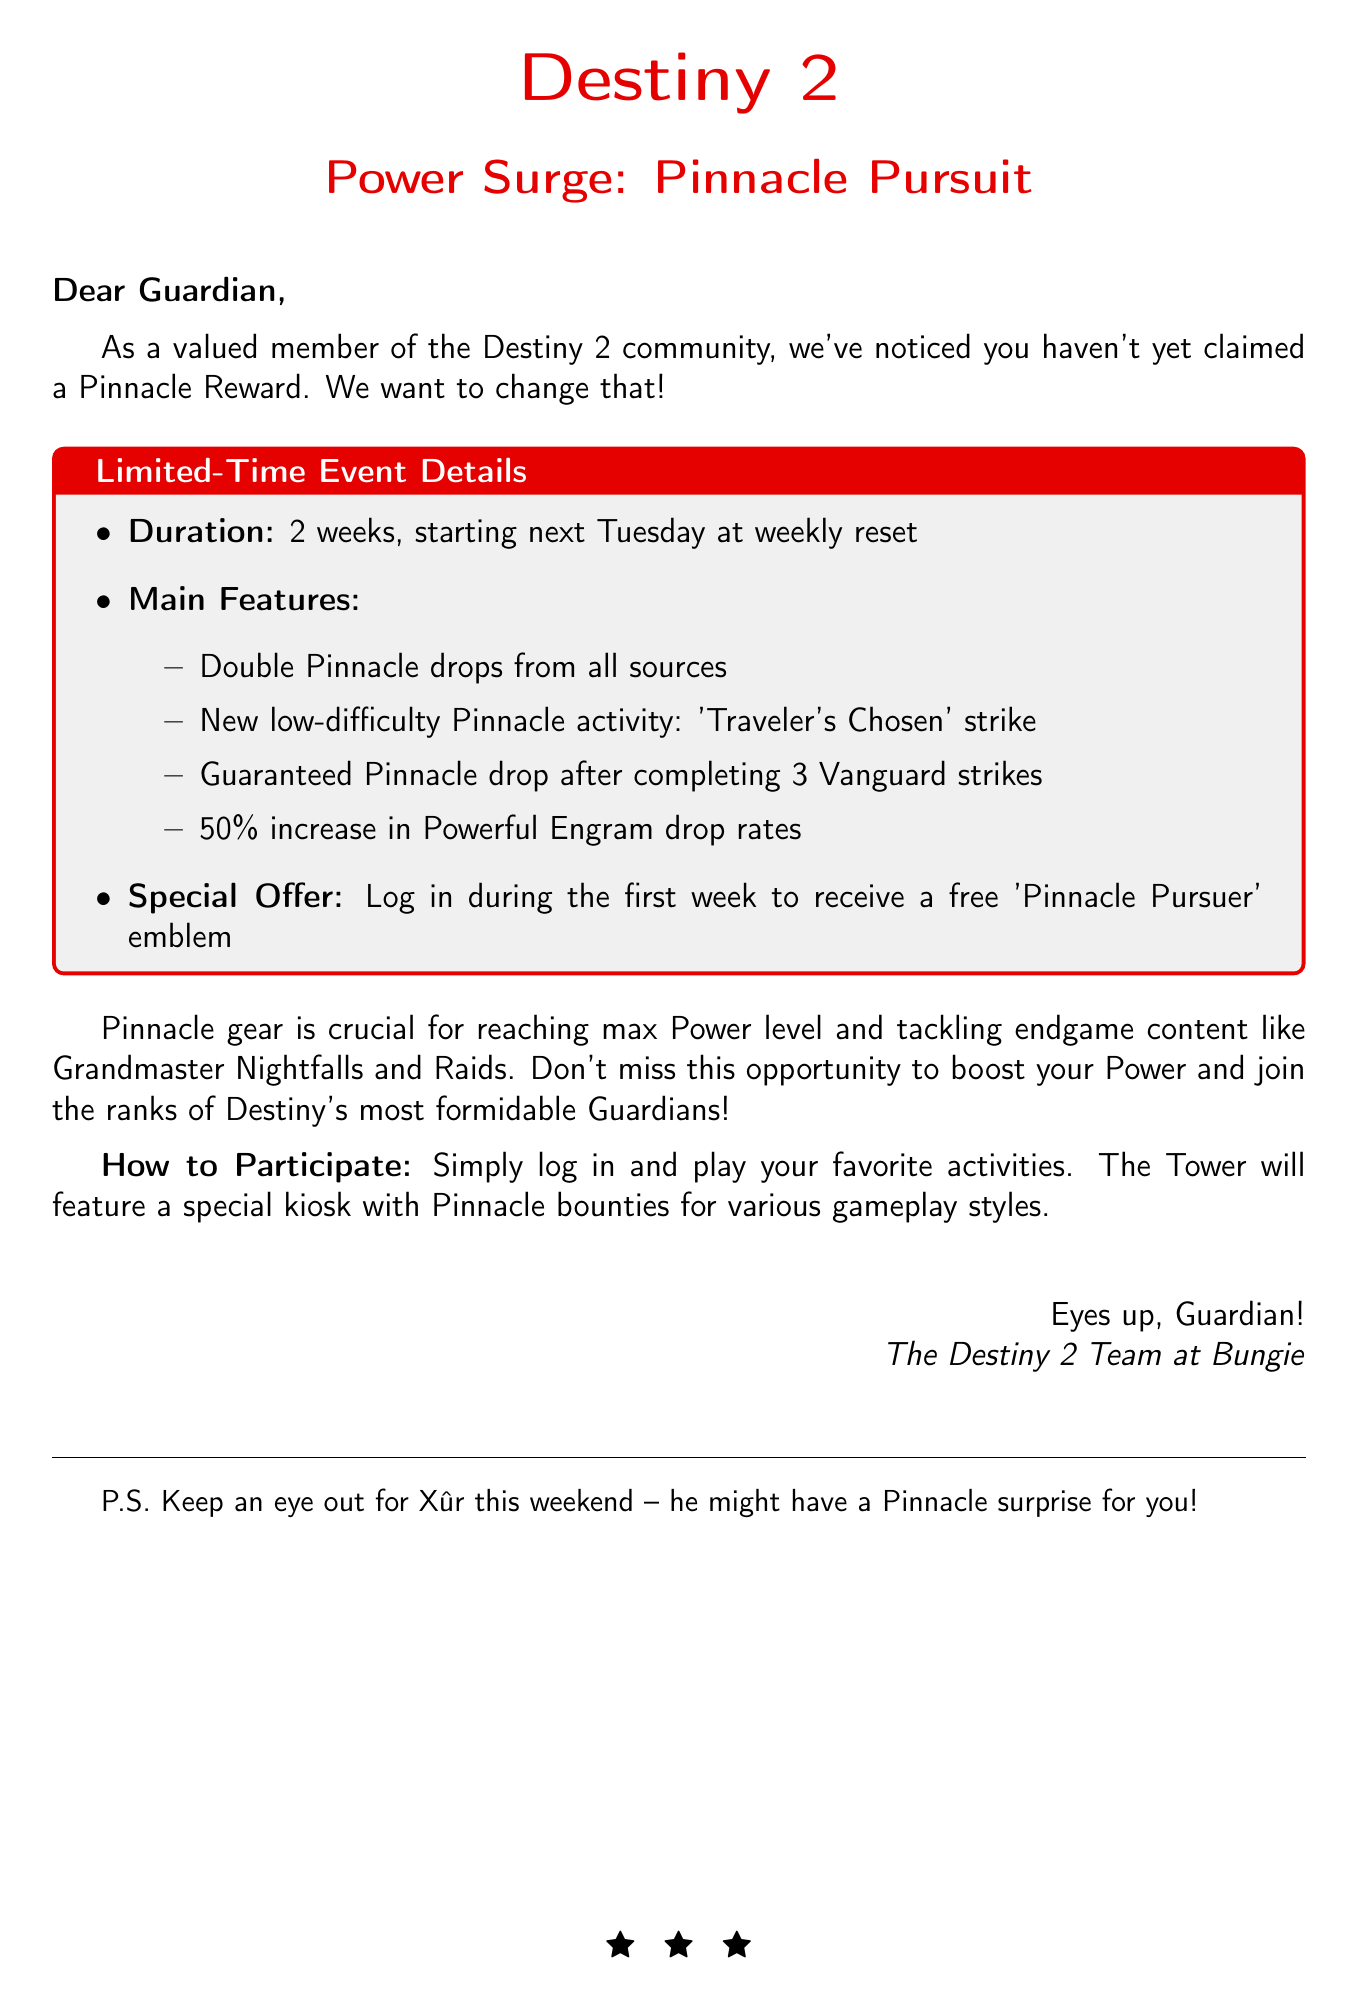What is the event name? The document mentions the event as "Power Surge: Pinnacle Pursuit."
Answer: Power Surge: Pinnacle Pursuit When does the event start? The email states that the event starts next Tuesday at weekly reset.
Answer: Next Tuesday How long will the event last? The document specifies that the event will last for 2 weeks.
Answer: 2 weeks What special offer is mentioned? The email includes a special offer of a free 'Pinnacle Pursuer' emblem for logging in during the first week.
Answer: Free 'Pinnacle Pursuer' emblem What can players receive after completing 3 Vanguard strikes? The document states that there will be a guaranteed Pinnacle drop after completing 3 Vanguard strikes.
Answer: Guaranteed Pinnacle drop What is the increase in Powerful Engram drop rates? The email specifies a 50% increase in Powerful Engram drop rates.
Answer: 50% What type of strike is introduced in the event? The document mentions a new low-difficulty Pinnacle activity named 'Traveler's Chosen' strike.
Answer: 'Traveler's Chosen' strike What should players do to participate? The email instructs players to simply log in and play their favorite activities.
Answer: Log in and play favorite activities Why is Pinnacle gear important? The document highlights that Pinnacle gear is crucial for reaching max Power level and tackling endgame content.
Answer: Crucial for max Power level and endgame content 